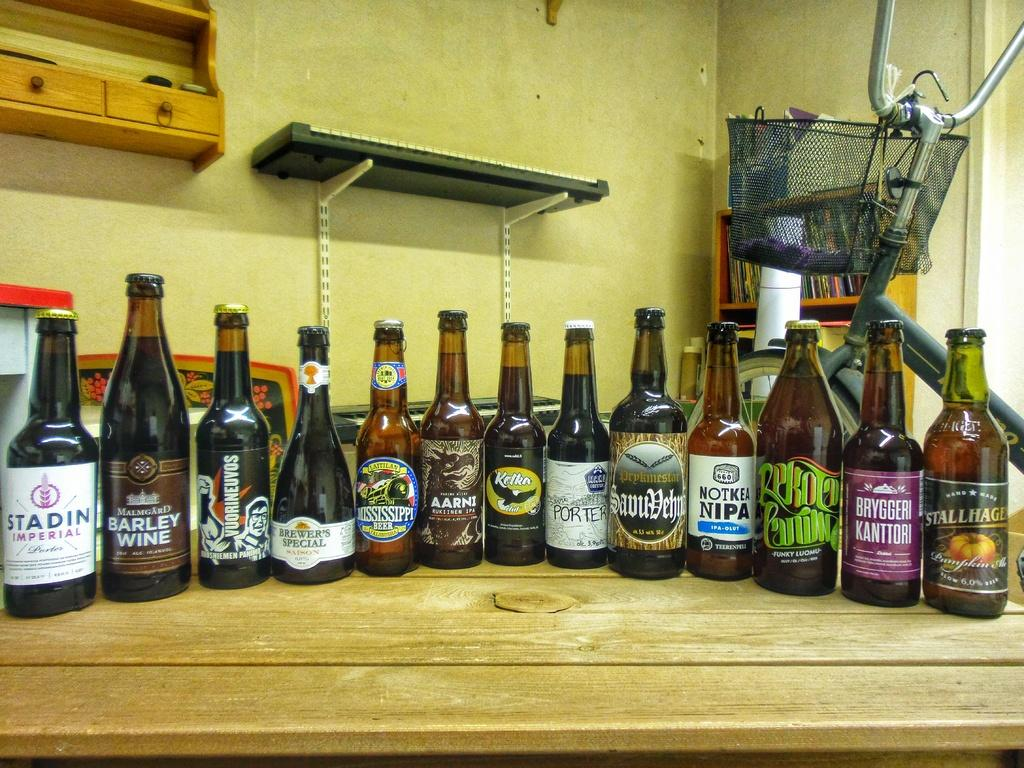What objects can be seen on the table in the image? There are bottles and a tray on the table in the image. What type of vehicle is present in the image? There is a bicycle with a basket in the image. What is the purpose of the bicycle rack in the image? The bicycle rack is filled with books. How many boats are visible in the image? There are no boats present in the image. What type of glove is being used to play the drum in the image? There is no glove or drum present in the image. 